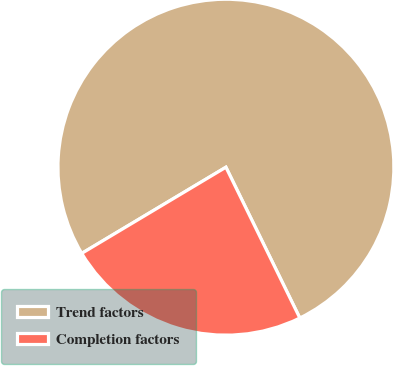Convert chart to OTSL. <chart><loc_0><loc_0><loc_500><loc_500><pie_chart><fcel>Trend factors<fcel>Completion factors<nl><fcel>76.32%<fcel>23.68%<nl></chart> 